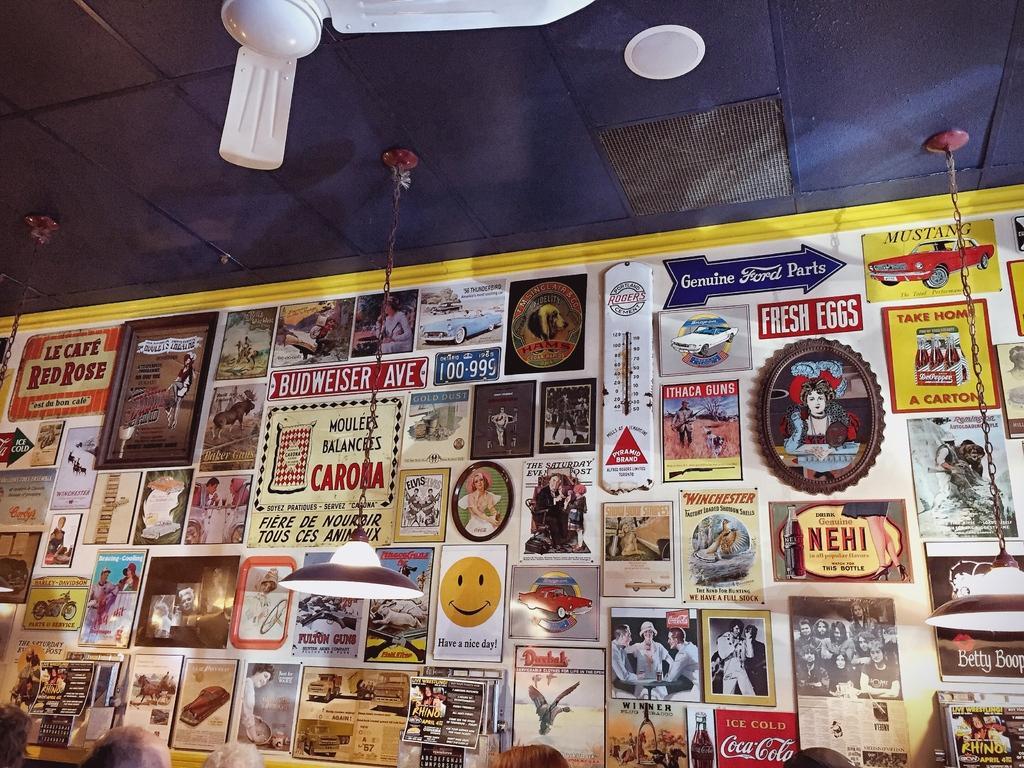Describe this image in one or two sentences. In this image in the front there are lights hanging, there are persons. In the background there is a board and on the board there are posters with some text and images on it. At the top there is a fan and there is an object which is white in colour. 